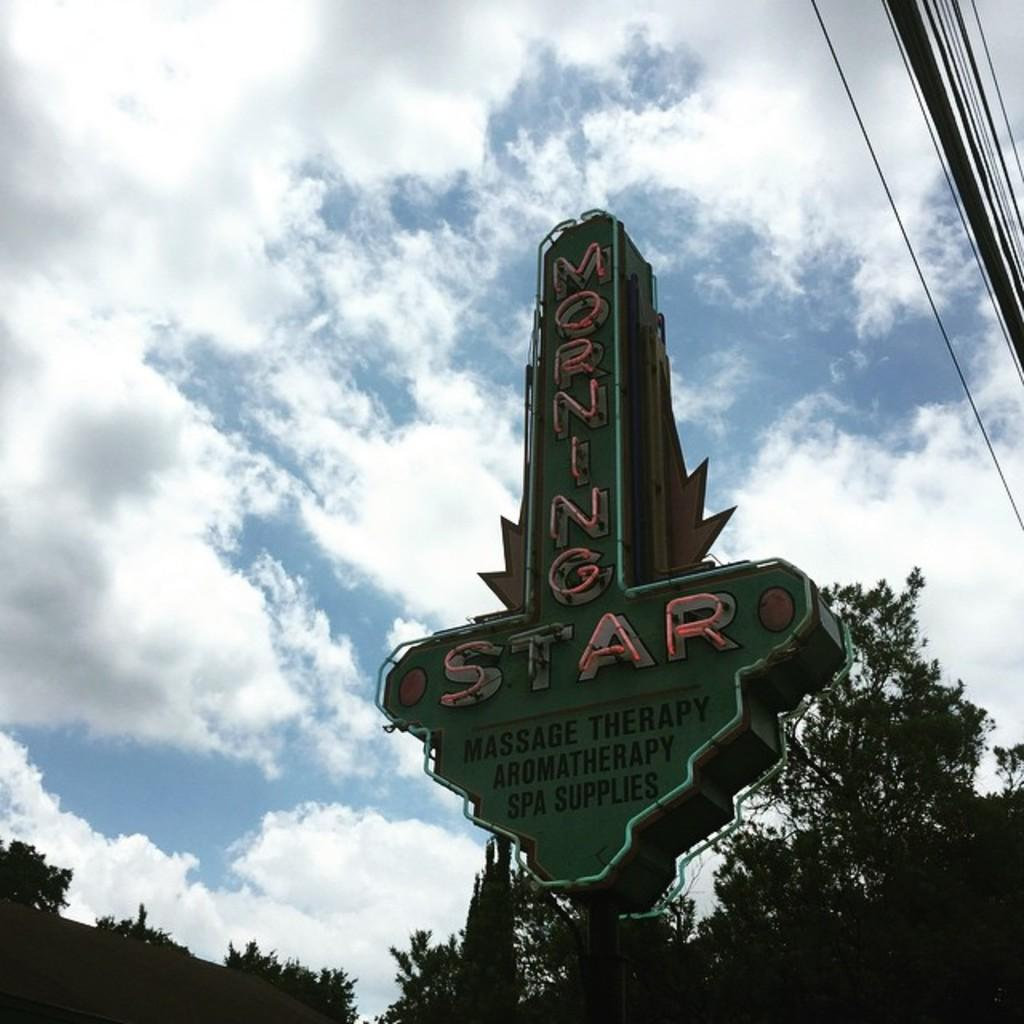What is the main object in the image? There is a green color board in the image. What is written on the green color board? There is something written on the board. What can be seen in the background of the image? There are trees and the sky visible in the background of the image. How would you describe the color of the sky in the image? The sky is a combination of blue and white colors. Can you see any pets playing with scissors in the image? There are no pets or scissors present in the image. Is there a net visible in the image? There is no net visible in the image. 